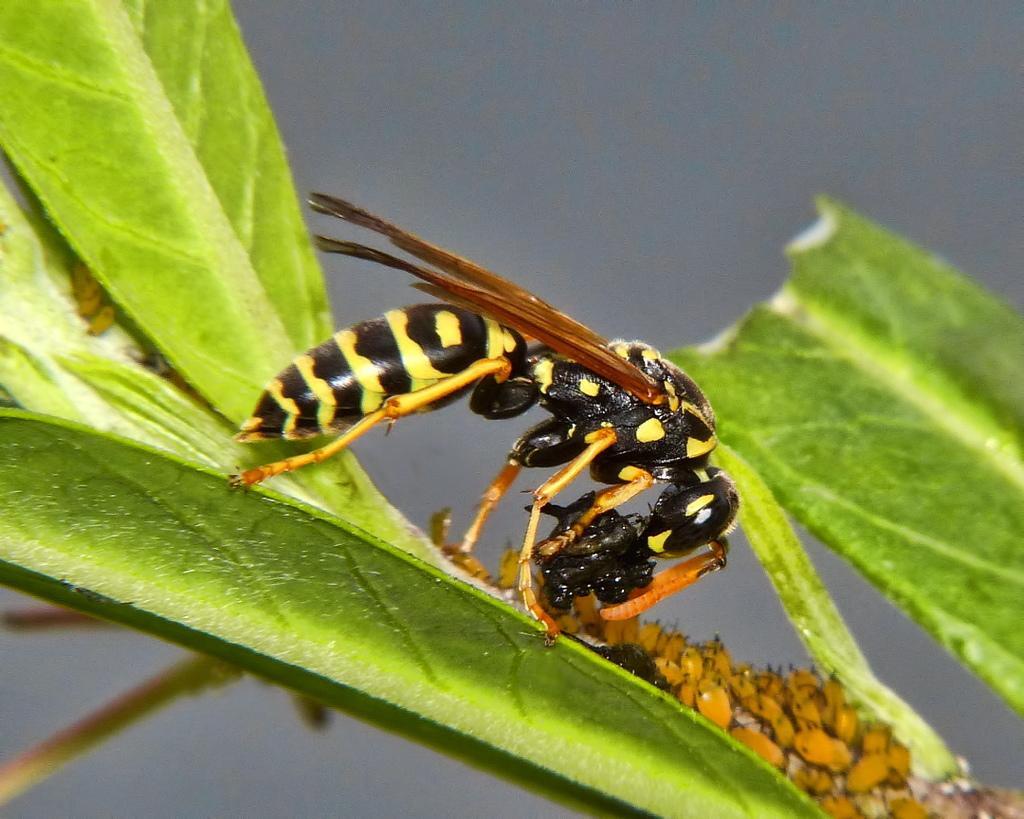Please provide a concise description of this image. This image is taken outdoors. In the background there is the sky. In the middle of the image there are a few leaves and there is a stem. There is an insect on the leaf. 